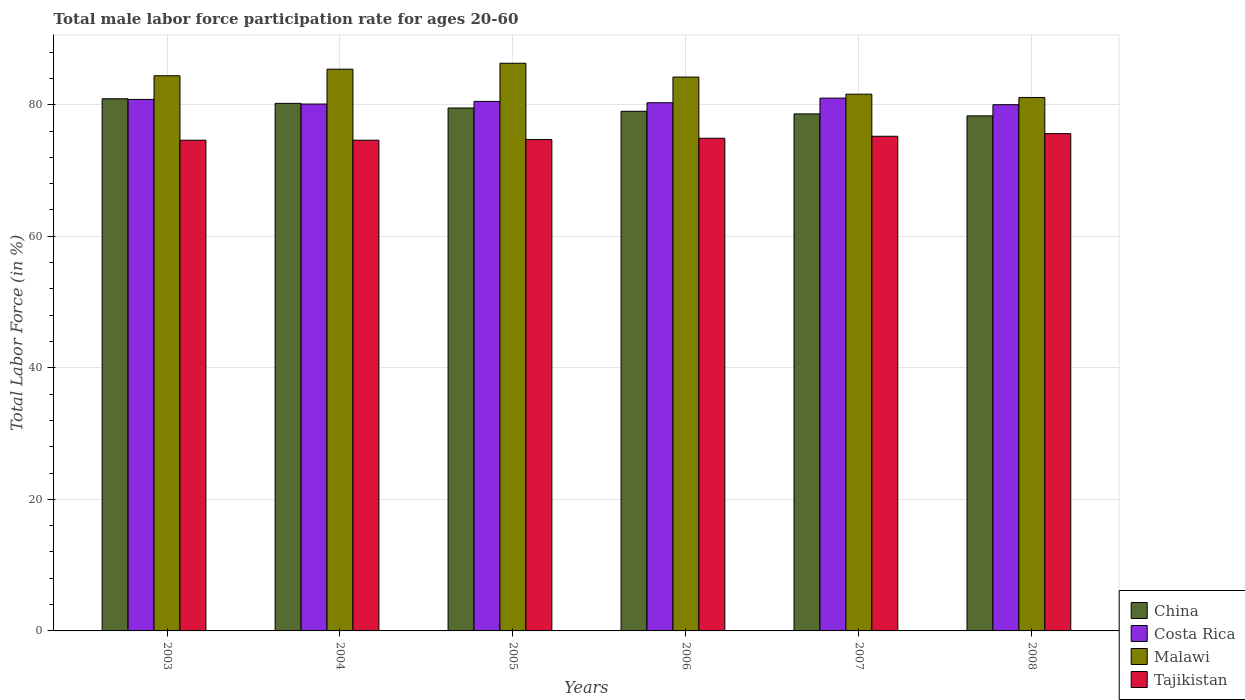Are the number of bars on each tick of the X-axis equal?
Your answer should be compact. Yes. How many bars are there on the 5th tick from the left?
Make the answer very short. 4. In how many cases, is the number of bars for a given year not equal to the number of legend labels?
Give a very brief answer. 0. What is the male labor force participation rate in Malawi in 2008?
Your response must be concise. 81.1. Across all years, what is the maximum male labor force participation rate in Tajikistan?
Make the answer very short. 75.6. Across all years, what is the minimum male labor force participation rate in Malawi?
Your answer should be compact. 81.1. In which year was the male labor force participation rate in Malawi maximum?
Keep it short and to the point. 2005. What is the total male labor force participation rate in Malawi in the graph?
Provide a short and direct response. 503. What is the difference between the male labor force participation rate in Malawi in 2003 and that in 2008?
Your response must be concise. 3.3. What is the difference between the male labor force participation rate in Malawi in 2006 and the male labor force participation rate in China in 2004?
Give a very brief answer. 4. What is the average male labor force participation rate in Malawi per year?
Make the answer very short. 83.83. In the year 2005, what is the difference between the male labor force participation rate in Tajikistan and male labor force participation rate in Malawi?
Your answer should be very brief. -11.6. In how many years, is the male labor force participation rate in Malawi greater than 80 %?
Provide a short and direct response. 6. What is the ratio of the male labor force participation rate in Malawi in 2003 to that in 2004?
Keep it short and to the point. 0.99. Is the difference between the male labor force participation rate in Tajikistan in 2005 and 2008 greater than the difference between the male labor force participation rate in Malawi in 2005 and 2008?
Give a very brief answer. No. What is the difference between the highest and the second highest male labor force participation rate in Malawi?
Provide a short and direct response. 0.9. What is the difference between the highest and the lowest male labor force participation rate in China?
Keep it short and to the point. 2.6. In how many years, is the male labor force participation rate in Malawi greater than the average male labor force participation rate in Malawi taken over all years?
Provide a succinct answer. 4. Is the sum of the male labor force participation rate in Costa Rica in 2003 and 2007 greater than the maximum male labor force participation rate in Tajikistan across all years?
Your response must be concise. Yes. What does the 3rd bar from the left in 2008 represents?
Offer a very short reply. Malawi. How many bars are there?
Make the answer very short. 24. What is the difference between two consecutive major ticks on the Y-axis?
Your answer should be compact. 20. Are the values on the major ticks of Y-axis written in scientific E-notation?
Ensure brevity in your answer.  No. Does the graph contain any zero values?
Your answer should be very brief. No. What is the title of the graph?
Your answer should be very brief. Total male labor force participation rate for ages 20-60. Does "Tunisia" appear as one of the legend labels in the graph?
Keep it short and to the point. No. What is the label or title of the X-axis?
Your answer should be very brief. Years. What is the Total Labor Force (in %) in China in 2003?
Offer a terse response. 80.9. What is the Total Labor Force (in %) in Costa Rica in 2003?
Give a very brief answer. 80.8. What is the Total Labor Force (in %) in Malawi in 2003?
Your answer should be compact. 84.4. What is the Total Labor Force (in %) in Tajikistan in 2003?
Keep it short and to the point. 74.6. What is the Total Labor Force (in %) in China in 2004?
Provide a short and direct response. 80.2. What is the Total Labor Force (in %) in Costa Rica in 2004?
Keep it short and to the point. 80.1. What is the Total Labor Force (in %) in Malawi in 2004?
Offer a very short reply. 85.4. What is the Total Labor Force (in %) of Tajikistan in 2004?
Your response must be concise. 74.6. What is the Total Labor Force (in %) of China in 2005?
Ensure brevity in your answer.  79.5. What is the Total Labor Force (in %) in Costa Rica in 2005?
Offer a terse response. 80.5. What is the Total Labor Force (in %) of Malawi in 2005?
Offer a very short reply. 86.3. What is the Total Labor Force (in %) in Tajikistan in 2005?
Your answer should be compact. 74.7. What is the Total Labor Force (in %) in China in 2006?
Ensure brevity in your answer.  79. What is the Total Labor Force (in %) in Costa Rica in 2006?
Your answer should be very brief. 80.3. What is the Total Labor Force (in %) in Malawi in 2006?
Provide a succinct answer. 84.2. What is the Total Labor Force (in %) in Tajikistan in 2006?
Give a very brief answer. 74.9. What is the Total Labor Force (in %) in China in 2007?
Offer a terse response. 78.6. What is the Total Labor Force (in %) of Costa Rica in 2007?
Provide a short and direct response. 81. What is the Total Labor Force (in %) of Malawi in 2007?
Offer a terse response. 81.6. What is the Total Labor Force (in %) in Tajikistan in 2007?
Your answer should be compact. 75.2. What is the Total Labor Force (in %) of China in 2008?
Provide a short and direct response. 78.3. What is the Total Labor Force (in %) in Costa Rica in 2008?
Provide a short and direct response. 80. What is the Total Labor Force (in %) in Malawi in 2008?
Your response must be concise. 81.1. What is the Total Labor Force (in %) of Tajikistan in 2008?
Keep it short and to the point. 75.6. Across all years, what is the maximum Total Labor Force (in %) in China?
Ensure brevity in your answer.  80.9. Across all years, what is the maximum Total Labor Force (in %) of Malawi?
Provide a short and direct response. 86.3. Across all years, what is the maximum Total Labor Force (in %) of Tajikistan?
Keep it short and to the point. 75.6. Across all years, what is the minimum Total Labor Force (in %) in China?
Ensure brevity in your answer.  78.3. Across all years, what is the minimum Total Labor Force (in %) in Costa Rica?
Your answer should be very brief. 80. Across all years, what is the minimum Total Labor Force (in %) in Malawi?
Provide a short and direct response. 81.1. Across all years, what is the minimum Total Labor Force (in %) of Tajikistan?
Give a very brief answer. 74.6. What is the total Total Labor Force (in %) in China in the graph?
Offer a very short reply. 476.5. What is the total Total Labor Force (in %) of Costa Rica in the graph?
Keep it short and to the point. 482.7. What is the total Total Labor Force (in %) of Malawi in the graph?
Provide a short and direct response. 503. What is the total Total Labor Force (in %) of Tajikistan in the graph?
Offer a terse response. 449.6. What is the difference between the Total Labor Force (in %) of China in 2003 and that in 2004?
Give a very brief answer. 0.7. What is the difference between the Total Labor Force (in %) in Costa Rica in 2003 and that in 2004?
Keep it short and to the point. 0.7. What is the difference between the Total Labor Force (in %) of Malawi in 2003 and that in 2004?
Your answer should be very brief. -1. What is the difference between the Total Labor Force (in %) in Tajikistan in 2003 and that in 2004?
Give a very brief answer. 0. What is the difference between the Total Labor Force (in %) in Costa Rica in 2003 and that in 2005?
Offer a very short reply. 0.3. What is the difference between the Total Labor Force (in %) of Tajikistan in 2003 and that in 2005?
Provide a short and direct response. -0.1. What is the difference between the Total Labor Force (in %) of Costa Rica in 2003 and that in 2006?
Your answer should be very brief. 0.5. What is the difference between the Total Labor Force (in %) in Tajikistan in 2003 and that in 2006?
Ensure brevity in your answer.  -0.3. What is the difference between the Total Labor Force (in %) in Tajikistan in 2003 and that in 2007?
Your answer should be compact. -0.6. What is the difference between the Total Labor Force (in %) of China in 2003 and that in 2008?
Keep it short and to the point. 2.6. What is the difference between the Total Labor Force (in %) in China in 2004 and that in 2005?
Provide a short and direct response. 0.7. What is the difference between the Total Labor Force (in %) in Costa Rica in 2004 and that in 2005?
Offer a very short reply. -0.4. What is the difference between the Total Labor Force (in %) of Malawi in 2004 and that in 2005?
Offer a very short reply. -0.9. What is the difference between the Total Labor Force (in %) of Tajikistan in 2004 and that in 2005?
Offer a terse response. -0.1. What is the difference between the Total Labor Force (in %) in Costa Rica in 2004 and that in 2006?
Offer a very short reply. -0.2. What is the difference between the Total Labor Force (in %) in Malawi in 2004 and that in 2006?
Your answer should be compact. 1.2. What is the difference between the Total Labor Force (in %) of Tajikistan in 2004 and that in 2006?
Your answer should be very brief. -0.3. What is the difference between the Total Labor Force (in %) in China in 2004 and that in 2007?
Offer a very short reply. 1.6. What is the difference between the Total Labor Force (in %) of Costa Rica in 2004 and that in 2007?
Your response must be concise. -0.9. What is the difference between the Total Labor Force (in %) of Malawi in 2004 and that in 2008?
Your answer should be very brief. 4.3. What is the difference between the Total Labor Force (in %) of Tajikistan in 2004 and that in 2008?
Your answer should be very brief. -1. What is the difference between the Total Labor Force (in %) of China in 2005 and that in 2006?
Ensure brevity in your answer.  0.5. What is the difference between the Total Labor Force (in %) of Costa Rica in 2005 and that in 2006?
Provide a short and direct response. 0.2. What is the difference between the Total Labor Force (in %) of Malawi in 2005 and that in 2006?
Your answer should be compact. 2.1. What is the difference between the Total Labor Force (in %) in Costa Rica in 2005 and that in 2007?
Give a very brief answer. -0.5. What is the difference between the Total Labor Force (in %) of Malawi in 2005 and that in 2007?
Make the answer very short. 4.7. What is the difference between the Total Labor Force (in %) in Tajikistan in 2005 and that in 2007?
Offer a very short reply. -0.5. What is the difference between the Total Labor Force (in %) in China in 2005 and that in 2008?
Offer a very short reply. 1.2. What is the difference between the Total Labor Force (in %) of Costa Rica in 2005 and that in 2008?
Keep it short and to the point. 0.5. What is the difference between the Total Labor Force (in %) in Malawi in 2005 and that in 2008?
Give a very brief answer. 5.2. What is the difference between the Total Labor Force (in %) of China in 2006 and that in 2007?
Provide a succinct answer. 0.4. What is the difference between the Total Labor Force (in %) in Tajikistan in 2006 and that in 2007?
Keep it short and to the point. -0.3. What is the difference between the Total Labor Force (in %) in Malawi in 2006 and that in 2008?
Ensure brevity in your answer.  3.1. What is the difference between the Total Labor Force (in %) in Tajikistan in 2006 and that in 2008?
Provide a succinct answer. -0.7. What is the difference between the Total Labor Force (in %) in Malawi in 2007 and that in 2008?
Offer a very short reply. 0.5. What is the difference between the Total Labor Force (in %) of China in 2003 and the Total Labor Force (in %) of Costa Rica in 2004?
Your response must be concise. 0.8. What is the difference between the Total Labor Force (in %) in China in 2003 and the Total Labor Force (in %) in Tajikistan in 2004?
Your answer should be compact. 6.3. What is the difference between the Total Labor Force (in %) of Costa Rica in 2003 and the Total Labor Force (in %) of Tajikistan in 2004?
Provide a short and direct response. 6.2. What is the difference between the Total Labor Force (in %) in Malawi in 2003 and the Total Labor Force (in %) in Tajikistan in 2004?
Provide a succinct answer. 9.8. What is the difference between the Total Labor Force (in %) of China in 2003 and the Total Labor Force (in %) of Costa Rica in 2005?
Your answer should be compact. 0.4. What is the difference between the Total Labor Force (in %) in China in 2003 and the Total Labor Force (in %) in Tajikistan in 2005?
Provide a succinct answer. 6.2. What is the difference between the Total Labor Force (in %) of Costa Rica in 2003 and the Total Labor Force (in %) of Malawi in 2005?
Provide a short and direct response. -5.5. What is the difference between the Total Labor Force (in %) in Malawi in 2003 and the Total Labor Force (in %) in Tajikistan in 2005?
Your response must be concise. 9.7. What is the difference between the Total Labor Force (in %) in Costa Rica in 2003 and the Total Labor Force (in %) in Tajikistan in 2006?
Ensure brevity in your answer.  5.9. What is the difference between the Total Labor Force (in %) in Malawi in 2003 and the Total Labor Force (in %) in Tajikistan in 2006?
Offer a very short reply. 9.5. What is the difference between the Total Labor Force (in %) in Malawi in 2003 and the Total Labor Force (in %) in Tajikistan in 2007?
Provide a succinct answer. 9.2. What is the difference between the Total Labor Force (in %) in China in 2003 and the Total Labor Force (in %) in Costa Rica in 2008?
Offer a very short reply. 0.9. What is the difference between the Total Labor Force (in %) of China in 2003 and the Total Labor Force (in %) of Tajikistan in 2008?
Provide a succinct answer. 5.3. What is the difference between the Total Labor Force (in %) of Costa Rica in 2003 and the Total Labor Force (in %) of Malawi in 2008?
Make the answer very short. -0.3. What is the difference between the Total Labor Force (in %) of Costa Rica in 2003 and the Total Labor Force (in %) of Tajikistan in 2008?
Provide a succinct answer. 5.2. What is the difference between the Total Labor Force (in %) in Malawi in 2003 and the Total Labor Force (in %) in Tajikistan in 2008?
Your answer should be very brief. 8.8. What is the difference between the Total Labor Force (in %) in China in 2004 and the Total Labor Force (in %) in Malawi in 2005?
Ensure brevity in your answer.  -6.1. What is the difference between the Total Labor Force (in %) in China in 2004 and the Total Labor Force (in %) in Tajikistan in 2005?
Give a very brief answer. 5.5. What is the difference between the Total Labor Force (in %) in Costa Rica in 2004 and the Total Labor Force (in %) in Malawi in 2005?
Your answer should be compact. -6.2. What is the difference between the Total Labor Force (in %) in Costa Rica in 2004 and the Total Labor Force (in %) in Tajikistan in 2005?
Offer a very short reply. 5.4. What is the difference between the Total Labor Force (in %) in China in 2004 and the Total Labor Force (in %) in Costa Rica in 2006?
Your answer should be compact. -0.1. What is the difference between the Total Labor Force (in %) of China in 2004 and the Total Labor Force (in %) of Malawi in 2006?
Your answer should be compact. -4. What is the difference between the Total Labor Force (in %) of Malawi in 2004 and the Total Labor Force (in %) of Tajikistan in 2006?
Give a very brief answer. 10.5. What is the difference between the Total Labor Force (in %) in China in 2004 and the Total Labor Force (in %) in Costa Rica in 2007?
Make the answer very short. -0.8. What is the difference between the Total Labor Force (in %) of China in 2004 and the Total Labor Force (in %) of Malawi in 2007?
Your answer should be compact. -1.4. What is the difference between the Total Labor Force (in %) of China in 2004 and the Total Labor Force (in %) of Tajikistan in 2007?
Offer a very short reply. 5. What is the difference between the Total Labor Force (in %) in Malawi in 2004 and the Total Labor Force (in %) in Tajikistan in 2007?
Make the answer very short. 10.2. What is the difference between the Total Labor Force (in %) in China in 2004 and the Total Labor Force (in %) in Costa Rica in 2008?
Provide a succinct answer. 0.2. What is the difference between the Total Labor Force (in %) of China in 2004 and the Total Labor Force (in %) of Malawi in 2008?
Offer a terse response. -0.9. What is the difference between the Total Labor Force (in %) in China in 2004 and the Total Labor Force (in %) in Tajikistan in 2008?
Provide a short and direct response. 4.6. What is the difference between the Total Labor Force (in %) in Costa Rica in 2004 and the Total Labor Force (in %) in Malawi in 2008?
Offer a terse response. -1. What is the difference between the Total Labor Force (in %) in Costa Rica in 2004 and the Total Labor Force (in %) in Tajikistan in 2008?
Provide a short and direct response. 4.5. What is the difference between the Total Labor Force (in %) in China in 2005 and the Total Labor Force (in %) in Malawi in 2006?
Provide a succinct answer. -4.7. What is the difference between the Total Labor Force (in %) in Costa Rica in 2005 and the Total Labor Force (in %) in Malawi in 2006?
Provide a short and direct response. -3.7. What is the difference between the Total Labor Force (in %) in Costa Rica in 2005 and the Total Labor Force (in %) in Tajikistan in 2006?
Offer a terse response. 5.6. What is the difference between the Total Labor Force (in %) of Costa Rica in 2005 and the Total Labor Force (in %) of Malawi in 2007?
Provide a short and direct response. -1.1. What is the difference between the Total Labor Force (in %) of China in 2005 and the Total Labor Force (in %) of Malawi in 2008?
Provide a short and direct response. -1.6. What is the difference between the Total Labor Force (in %) in China in 2005 and the Total Labor Force (in %) in Tajikistan in 2008?
Provide a short and direct response. 3.9. What is the difference between the Total Labor Force (in %) of Costa Rica in 2005 and the Total Labor Force (in %) of Tajikistan in 2008?
Provide a succinct answer. 4.9. What is the difference between the Total Labor Force (in %) in China in 2006 and the Total Labor Force (in %) in Tajikistan in 2007?
Offer a very short reply. 3.8. What is the difference between the Total Labor Force (in %) in Costa Rica in 2006 and the Total Labor Force (in %) in Tajikistan in 2007?
Ensure brevity in your answer.  5.1. What is the difference between the Total Labor Force (in %) of China in 2006 and the Total Labor Force (in %) of Tajikistan in 2008?
Ensure brevity in your answer.  3.4. What is the difference between the Total Labor Force (in %) of Costa Rica in 2006 and the Total Labor Force (in %) of Malawi in 2008?
Offer a terse response. -0.8. What is the difference between the Total Labor Force (in %) of China in 2007 and the Total Labor Force (in %) of Costa Rica in 2008?
Ensure brevity in your answer.  -1.4. What is the difference between the Total Labor Force (in %) in Costa Rica in 2007 and the Total Labor Force (in %) in Tajikistan in 2008?
Offer a terse response. 5.4. What is the average Total Labor Force (in %) in China per year?
Your response must be concise. 79.42. What is the average Total Labor Force (in %) in Costa Rica per year?
Your answer should be compact. 80.45. What is the average Total Labor Force (in %) of Malawi per year?
Provide a short and direct response. 83.83. What is the average Total Labor Force (in %) of Tajikistan per year?
Offer a terse response. 74.93. In the year 2003, what is the difference between the Total Labor Force (in %) of Malawi and Total Labor Force (in %) of Tajikistan?
Offer a terse response. 9.8. In the year 2004, what is the difference between the Total Labor Force (in %) of China and Total Labor Force (in %) of Costa Rica?
Your answer should be very brief. 0.1. In the year 2004, what is the difference between the Total Labor Force (in %) in China and Total Labor Force (in %) in Malawi?
Give a very brief answer. -5.2. In the year 2004, what is the difference between the Total Labor Force (in %) of China and Total Labor Force (in %) of Tajikistan?
Give a very brief answer. 5.6. In the year 2004, what is the difference between the Total Labor Force (in %) of Costa Rica and Total Labor Force (in %) of Malawi?
Provide a succinct answer. -5.3. In the year 2005, what is the difference between the Total Labor Force (in %) of China and Total Labor Force (in %) of Tajikistan?
Your response must be concise. 4.8. In the year 2005, what is the difference between the Total Labor Force (in %) in Costa Rica and Total Labor Force (in %) in Malawi?
Offer a very short reply. -5.8. In the year 2005, what is the difference between the Total Labor Force (in %) in Costa Rica and Total Labor Force (in %) in Tajikistan?
Offer a terse response. 5.8. In the year 2005, what is the difference between the Total Labor Force (in %) in Malawi and Total Labor Force (in %) in Tajikistan?
Make the answer very short. 11.6. In the year 2006, what is the difference between the Total Labor Force (in %) in China and Total Labor Force (in %) in Costa Rica?
Your answer should be compact. -1.3. In the year 2006, what is the difference between the Total Labor Force (in %) in China and Total Labor Force (in %) in Tajikistan?
Make the answer very short. 4.1. In the year 2007, what is the difference between the Total Labor Force (in %) in China and Total Labor Force (in %) in Costa Rica?
Your answer should be compact. -2.4. In the year 2007, what is the difference between the Total Labor Force (in %) in China and Total Labor Force (in %) in Tajikistan?
Make the answer very short. 3.4. In the year 2007, what is the difference between the Total Labor Force (in %) of Costa Rica and Total Labor Force (in %) of Tajikistan?
Make the answer very short. 5.8. In the year 2008, what is the difference between the Total Labor Force (in %) of China and Total Labor Force (in %) of Malawi?
Keep it short and to the point. -2.8. In the year 2008, what is the difference between the Total Labor Force (in %) in Malawi and Total Labor Force (in %) in Tajikistan?
Keep it short and to the point. 5.5. What is the ratio of the Total Labor Force (in %) in China in 2003 to that in 2004?
Give a very brief answer. 1.01. What is the ratio of the Total Labor Force (in %) of Costa Rica in 2003 to that in 2004?
Keep it short and to the point. 1.01. What is the ratio of the Total Labor Force (in %) in Malawi in 2003 to that in 2004?
Your response must be concise. 0.99. What is the ratio of the Total Labor Force (in %) in China in 2003 to that in 2005?
Provide a short and direct response. 1.02. What is the ratio of the Total Labor Force (in %) of Costa Rica in 2003 to that in 2005?
Your answer should be compact. 1. What is the ratio of the Total Labor Force (in %) of China in 2003 to that in 2006?
Offer a terse response. 1.02. What is the ratio of the Total Labor Force (in %) in Malawi in 2003 to that in 2006?
Your response must be concise. 1. What is the ratio of the Total Labor Force (in %) in Tajikistan in 2003 to that in 2006?
Provide a succinct answer. 1. What is the ratio of the Total Labor Force (in %) of China in 2003 to that in 2007?
Provide a succinct answer. 1.03. What is the ratio of the Total Labor Force (in %) in Costa Rica in 2003 to that in 2007?
Offer a terse response. 1. What is the ratio of the Total Labor Force (in %) in Malawi in 2003 to that in 2007?
Ensure brevity in your answer.  1.03. What is the ratio of the Total Labor Force (in %) in Tajikistan in 2003 to that in 2007?
Give a very brief answer. 0.99. What is the ratio of the Total Labor Force (in %) in China in 2003 to that in 2008?
Provide a succinct answer. 1.03. What is the ratio of the Total Labor Force (in %) in Costa Rica in 2003 to that in 2008?
Give a very brief answer. 1.01. What is the ratio of the Total Labor Force (in %) of Malawi in 2003 to that in 2008?
Your answer should be very brief. 1.04. What is the ratio of the Total Labor Force (in %) of Tajikistan in 2003 to that in 2008?
Provide a short and direct response. 0.99. What is the ratio of the Total Labor Force (in %) in China in 2004 to that in 2005?
Provide a succinct answer. 1.01. What is the ratio of the Total Labor Force (in %) of Costa Rica in 2004 to that in 2005?
Your answer should be compact. 0.99. What is the ratio of the Total Labor Force (in %) in China in 2004 to that in 2006?
Your answer should be very brief. 1.02. What is the ratio of the Total Labor Force (in %) of Costa Rica in 2004 to that in 2006?
Your response must be concise. 1. What is the ratio of the Total Labor Force (in %) of Malawi in 2004 to that in 2006?
Your answer should be compact. 1.01. What is the ratio of the Total Labor Force (in %) in China in 2004 to that in 2007?
Your answer should be compact. 1.02. What is the ratio of the Total Labor Force (in %) of Costa Rica in 2004 to that in 2007?
Your answer should be very brief. 0.99. What is the ratio of the Total Labor Force (in %) of Malawi in 2004 to that in 2007?
Keep it short and to the point. 1.05. What is the ratio of the Total Labor Force (in %) in China in 2004 to that in 2008?
Keep it short and to the point. 1.02. What is the ratio of the Total Labor Force (in %) in Costa Rica in 2004 to that in 2008?
Offer a very short reply. 1. What is the ratio of the Total Labor Force (in %) of Malawi in 2004 to that in 2008?
Your answer should be compact. 1.05. What is the ratio of the Total Labor Force (in %) in Tajikistan in 2004 to that in 2008?
Your response must be concise. 0.99. What is the ratio of the Total Labor Force (in %) of Malawi in 2005 to that in 2006?
Keep it short and to the point. 1.02. What is the ratio of the Total Labor Force (in %) in China in 2005 to that in 2007?
Offer a terse response. 1.01. What is the ratio of the Total Labor Force (in %) of Malawi in 2005 to that in 2007?
Your response must be concise. 1.06. What is the ratio of the Total Labor Force (in %) of Tajikistan in 2005 to that in 2007?
Provide a succinct answer. 0.99. What is the ratio of the Total Labor Force (in %) of China in 2005 to that in 2008?
Offer a very short reply. 1.02. What is the ratio of the Total Labor Force (in %) of Costa Rica in 2005 to that in 2008?
Your answer should be very brief. 1.01. What is the ratio of the Total Labor Force (in %) of Malawi in 2005 to that in 2008?
Your answer should be very brief. 1.06. What is the ratio of the Total Labor Force (in %) in China in 2006 to that in 2007?
Make the answer very short. 1.01. What is the ratio of the Total Labor Force (in %) in Malawi in 2006 to that in 2007?
Offer a terse response. 1.03. What is the ratio of the Total Labor Force (in %) in Tajikistan in 2006 to that in 2007?
Your response must be concise. 1. What is the ratio of the Total Labor Force (in %) of China in 2006 to that in 2008?
Offer a terse response. 1.01. What is the ratio of the Total Labor Force (in %) in Costa Rica in 2006 to that in 2008?
Offer a very short reply. 1. What is the ratio of the Total Labor Force (in %) of Malawi in 2006 to that in 2008?
Provide a short and direct response. 1.04. What is the ratio of the Total Labor Force (in %) in Tajikistan in 2006 to that in 2008?
Provide a short and direct response. 0.99. What is the ratio of the Total Labor Force (in %) in China in 2007 to that in 2008?
Offer a very short reply. 1. What is the ratio of the Total Labor Force (in %) in Costa Rica in 2007 to that in 2008?
Keep it short and to the point. 1.01. What is the ratio of the Total Labor Force (in %) of Malawi in 2007 to that in 2008?
Your answer should be compact. 1.01. What is the ratio of the Total Labor Force (in %) in Tajikistan in 2007 to that in 2008?
Provide a short and direct response. 0.99. What is the difference between the highest and the second highest Total Labor Force (in %) in Costa Rica?
Your answer should be very brief. 0.2. What is the difference between the highest and the lowest Total Labor Force (in %) in China?
Your response must be concise. 2.6. 